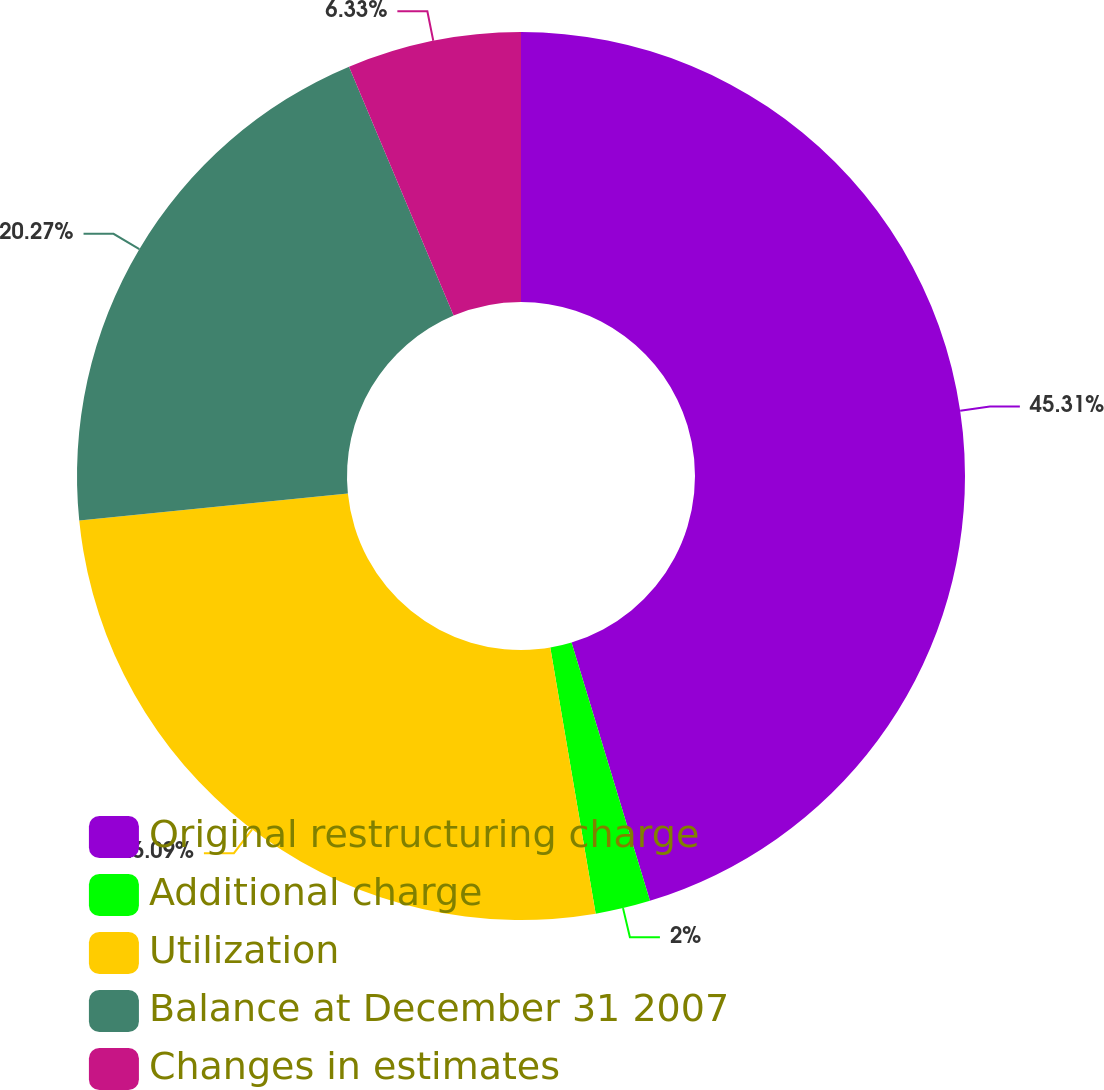Convert chart to OTSL. <chart><loc_0><loc_0><loc_500><loc_500><pie_chart><fcel>Original restructuring charge<fcel>Additional charge<fcel>Utilization<fcel>Balance at December 31 2007<fcel>Changes in estimates<nl><fcel>45.31%<fcel>2.0%<fcel>26.09%<fcel>20.27%<fcel>6.33%<nl></chart> 